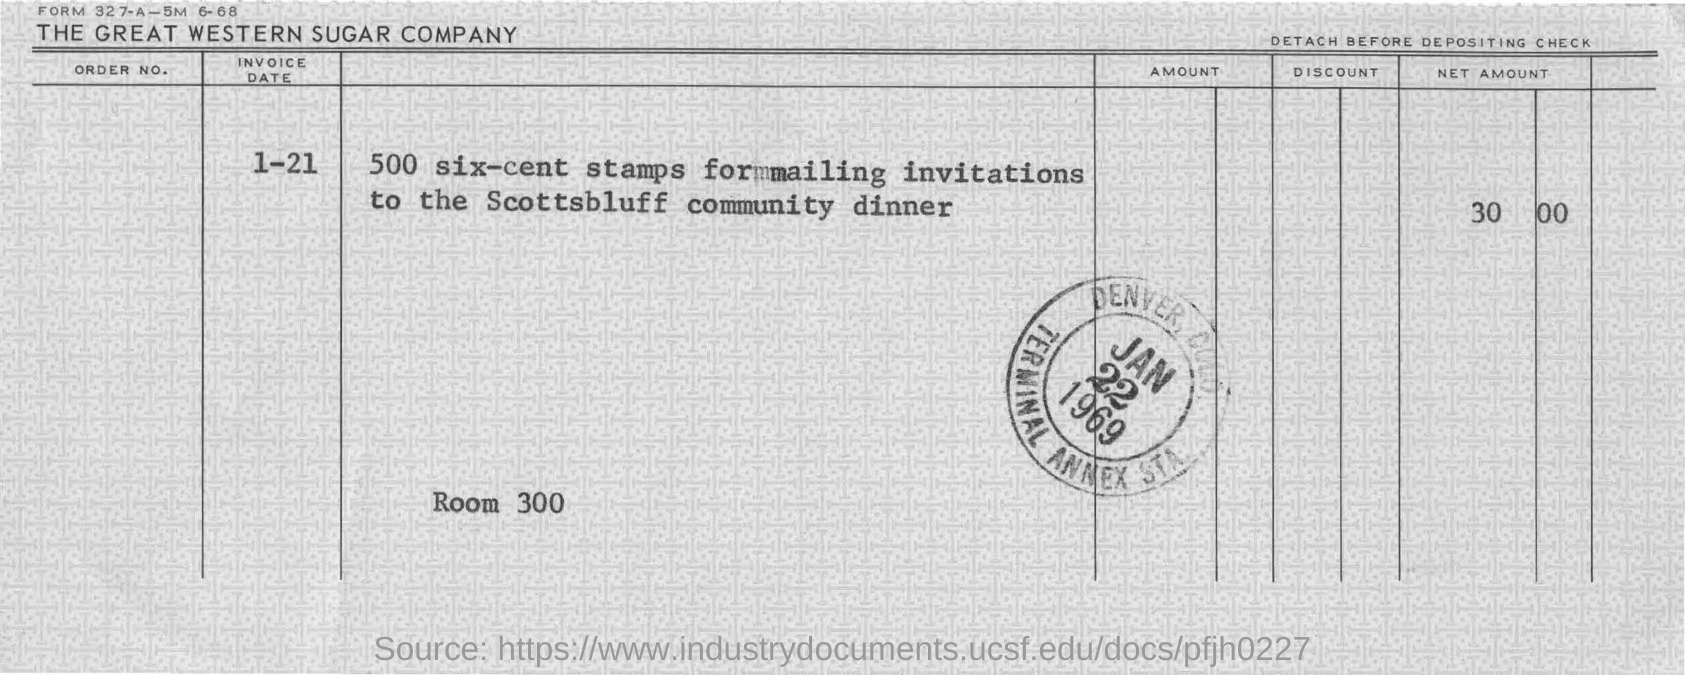Mention a couple of crucial points in this snapshot. It is necessary to use 500 six-cent stamps to mail invitations. The invitations should be mailed for the Scottsbluff community dinner. The stamp is dated January 22, 1969. The invoice date is January 21st. 